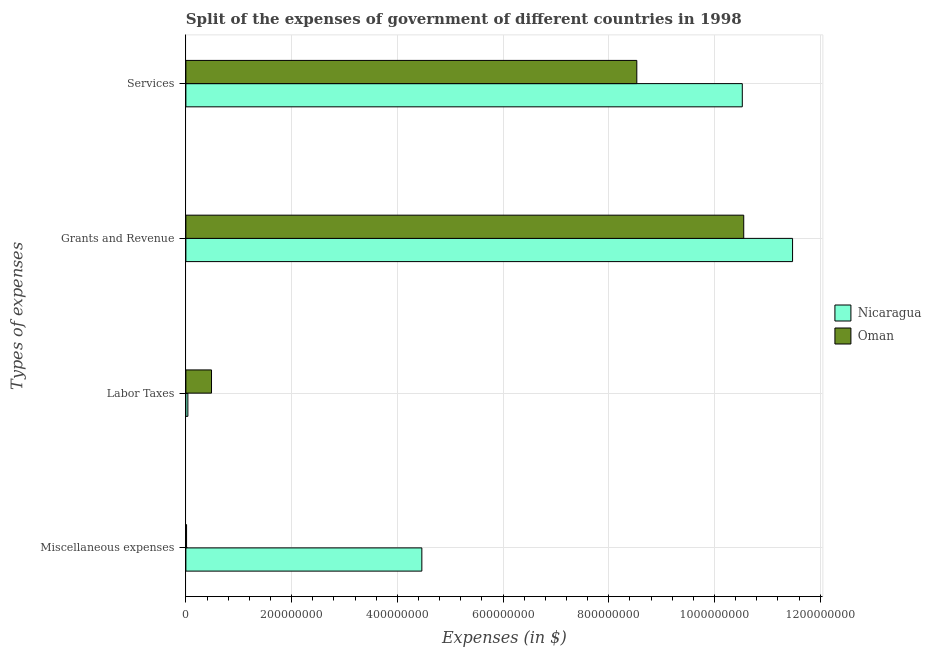How many different coloured bars are there?
Provide a short and direct response. 2. How many groups of bars are there?
Provide a short and direct response. 4. Are the number of bars per tick equal to the number of legend labels?
Your answer should be compact. Yes. How many bars are there on the 1st tick from the bottom?
Your answer should be compact. 2. What is the label of the 4th group of bars from the top?
Provide a succinct answer. Miscellaneous expenses. What is the amount spent on miscellaneous expenses in Nicaragua?
Your answer should be compact. 4.46e+08. Across all countries, what is the maximum amount spent on miscellaneous expenses?
Your answer should be compact. 4.46e+08. Across all countries, what is the minimum amount spent on grants and revenue?
Provide a short and direct response. 1.06e+09. In which country was the amount spent on labor taxes maximum?
Provide a short and direct response. Oman. In which country was the amount spent on services minimum?
Your answer should be compact. Oman. What is the total amount spent on services in the graph?
Keep it short and to the point. 1.91e+09. What is the difference between the amount spent on labor taxes in Nicaragua and that in Oman?
Your response must be concise. -4.47e+07. What is the difference between the amount spent on labor taxes in Oman and the amount spent on services in Nicaragua?
Keep it short and to the point. -1.00e+09. What is the average amount spent on services per country?
Your response must be concise. 9.53e+08. What is the difference between the amount spent on miscellaneous expenses and amount spent on grants and revenue in Oman?
Offer a terse response. -1.05e+09. What is the ratio of the amount spent on grants and revenue in Nicaragua to that in Oman?
Your response must be concise. 1.09. What is the difference between the highest and the second highest amount spent on labor taxes?
Your answer should be very brief. 4.47e+07. What is the difference between the highest and the lowest amount spent on services?
Offer a terse response. 2.00e+08. In how many countries, is the amount spent on grants and revenue greater than the average amount spent on grants and revenue taken over all countries?
Offer a very short reply. 1. What does the 2nd bar from the top in Labor Taxes represents?
Give a very brief answer. Nicaragua. What does the 2nd bar from the bottom in Services represents?
Provide a short and direct response. Oman. How many bars are there?
Keep it short and to the point. 8. Are the values on the major ticks of X-axis written in scientific E-notation?
Keep it short and to the point. No. Where does the legend appear in the graph?
Keep it short and to the point. Center right. How many legend labels are there?
Your response must be concise. 2. How are the legend labels stacked?
Provide a succinct answer. Vertical. What is the title of the graph?
Ensure brevity in your answer.  Split of the expenses of government of different countries in 1998. What is the label or title of the X-axis?
Offer a very short reply. Expenses (in $). What is the label or title of the Y-axis?
Keep it short and to the point. Types of expenses. What is the Expenses (in $) in Nicaragua in Miscellaneous expenses?
Provide a short and direct response. 4.46e+08. What is the Expenses (in $) in Oman in Miscellaneous expenses?
Your answer should be compact. 1.30e+06. What is the Expenses (in $) of Nicaragua in Labor Taxes?
Offer a terse response. 3.78e+06. What is the Expenses (in $) in Oman in Labor Taxes?
Keep it short and to the point. 4.85e+07. What is the Expenses (in $) of Nicaragua in Grants and Revenue?
Your response must be concise. 1.15e+09. What is the Expenses (in $) of Oman in Grants and Revenue?
Your answer should be very brief. 1.06e+09. What is the Expenses (in $) of Nicaragua in Services?
Provide a short and direct response. 1.05e+09. What is the Expenses (in $) in Oman in Services?
Offer a very short reply. 8.53e+08. Across all Types of expenses, what is the maximum Expenses (in $) of Nicaragua?
Ensure brevity in your answer.  1.15e+09. Across all Types of expenses, what is the maximum Expenses (in $) in Oman?
Offer a very short reply. 1.06e+09. Across all Types of expenses, what is the minimum Expenses (in $) in Nicaragua?
Provide a succinct answer. 3.78e+06. Across all Types of expenses, what is the minimum Expenses (in $) of Oman?
Your answer should be compact. 1.30e+06. What is the total Expenses (in $) of Nicaragua in the graph?
Ensure brevity in your answer.  2.65e+09. What is the total Expenses (in $) in Oman in the graph?
Your answer should be very brief. 1.96e+09. What is the difference between the Expenses (in $) of Nicaragua in Miscellaneous expenses and that in Labor Taxes?
Ensure brevity in your answer.  4.43e+08. What is the difference between the Expenses (in $) of Oman in Miscellaneous expenses and that in Labor Taxes?
Your response must be concise. -4.72e+07. What is the difference between the Expenses (in $) in Nicaragua in Miscellaneous expenses and that in Grants and Revenue?
Your response must be concise. -7.01e+08. What is the difference between the Expenses (in $) of Oman in Miscellaneous expenses and that in Grants and Revenue?
Your response must be concise. -1.05e+09. What is the difference between the Expenses (in $) of Nicaragua in Miscellaneous expenses and that in Services?
Keep it short and to the point. -6.06e+08. What is the difference between the Expenses (in $) in Oman in Miscellaneous expenses and that in Services?
Ensure brevity in your answer.  -8.52e+08. What is the difference between the Expenses (in $) of Nicaragua in Labor Taxes and that in Grants and Revenue?
Your answer should be compact. -1.14e+09. What is the difference between the Expenses (in $) in Oman in Labor Taxes and that in Grants and Revenue?
Make the answer very short. -1.01e+09. What is the difference between the Expenses (in $) in Nicaragua in Labor Taxes and that in Services?
Provide a short and direct response. -1.05e+09. What is the difference between the Expenses (in $) in Oman in Labor Taxes and that in Services?
Provide a short and direct response. -8.05e+08. What is the difference between the Expenses (in $) in Nicaragua in Grants and Revenue and that in Services?
Your response must be concise. 9.51e+07. What is the difference between the Expenses (in $) of Oman in Grants and Revenue and that in Services?
Make the answer very short. 2.02e+08. What is the difference between the Expenses (in $) in Nicaragua in Miscellaneous expenses and the Expenses (in $) in Oman in Labor Taxes?
Give a very brief answer. 3.98e+08. What is the difference between the Expenses (in $) of Nicaragua in Miscellaneous expenses and the Expenses (in $) of Oman in Grants and Revenue?
Make the answer very short. -6.09e+08. What is the difference between the Expenses (in $) of Nicaragua in Miscellaneous expenses and the Expenses (in $) of Oman in Services?
Your answer should be very brief. -4.07e+08. What is the difference between the Expenses (in $) of Nicaragua in Labor Taxes and the Expenses (in $) of Oman in Grants and Revenue?
Offer a very short reply. -1.05e+09. What is the difference between the Expenses (in $) of Nicaragua in Labor Taxes and the Expenses (in $) of Oman in Services?
Provide a short and direct response. -8.49e+08. What is the difference between the Expenses (in $) of Nicaragua in Grants and Revenue and the Expenses (in $) of Oman in Services?
Ensure brevity in your answer.  2.95e+08. What is the average Expenses (in $) of Nicaragua per Types of expenses?
Your answer should be very brief. 6.63e+08. What is the average Expenses (in $) of Oman per Types of expenses?
Your response must be concise. 4.90e+08. What is the difference between the Expenses (in $) of Nicaragua and Expenses (in $) of Oman in Miscellaneous expenses?
Provide a succinct answer. 4.45e+08. What is the difference between the Expenses (in $) in Nicaragua and Expenses (in $) in Oman in Labor Taxes?
Your answer should be compact. -4.47e+07. What is the difference between the Expenses (in $) of Nicaragua and Expenses (in $) of Oman in Grants and Revenue?
Offer a very short reply. 9.24e+07. What is the difference between the Expenses (in $) in Nicaragua and Expenses (in $) in Oman in Services?
Keep it short and to the point. 2.00e+08. What is the ratio of the Expenses (in $) in Nicaragua in Miscellaneous expenses to that in Labor Taxes?
Keep it short and to the point. 118.1. What is the ratio of the Expenses (in $) of Oman in Miscellaneous expenses to that in Labor Taxes?
Offer a very short reply. 0.03. What is the ratio of the Expenses (in $) in Nicaragua in Miscellaneous expenses to that in Grants and Revenue?
Offer a very short reply. 0.39. What is the ratio of the Expenses (in $) of Oman in Miscellaneous expenses to that in Grants and Revenue?
Provide a succinct answer. 0. What is the ratio of the Expenses (in $) in Nicaragua in Miscellaneous expenses to that in Services?
Give a very brief answer. 0.42. What is the ratio of the Expenses (in $) of Oman in Miscellaneous expenses to that in Services?
Your response must be concise. 0. What is the ratio of the Expenses (in $) in Nicaragua in Labor Taxes to that in Grants and Revenue?
Provide a succinct answer. 0. What is the ratio of the Expenses (in $) in Oman in Labor Taxes to that in Grants and Revenue?
Ensure brevity in your answer.  0.05. What is the ratio of the Expenses (in $) of Nicaragua in Labor Taxes to that in Services?
Offer a terse response. 0. What is the ratio of the Expenses (in $) in Oman in Labor Taxes to that in Services?
Ensure brevity in your answer.  0.06. What is the ratio of the Expenses (in $) in Nicaragua in Grants and Revenue to that in Services?
Your response must be concise. 1.09. What is the ratio of the Expenses (in $) of Oman in Grants and Revenue to that in Services?
Keep it short and to the point. 1.24. What is the difference between the highest and the second highest Expenses (in $) in Nicaragua?
Ensure brevity in your answer.  9.51e+07. What is the difference between the highest and the second highest Expenses (in $) in Oman?
Provide a succinct answer. 2.02e+08. What is the difference between the highest and the lowest Expenses (in $) in Nicaragua?
Make the answer very short. 1.14e+09. What is the difference between the highest and the lowest Expenses (in $) of Oman?
Your answer should be compact. 1.05e+09. 